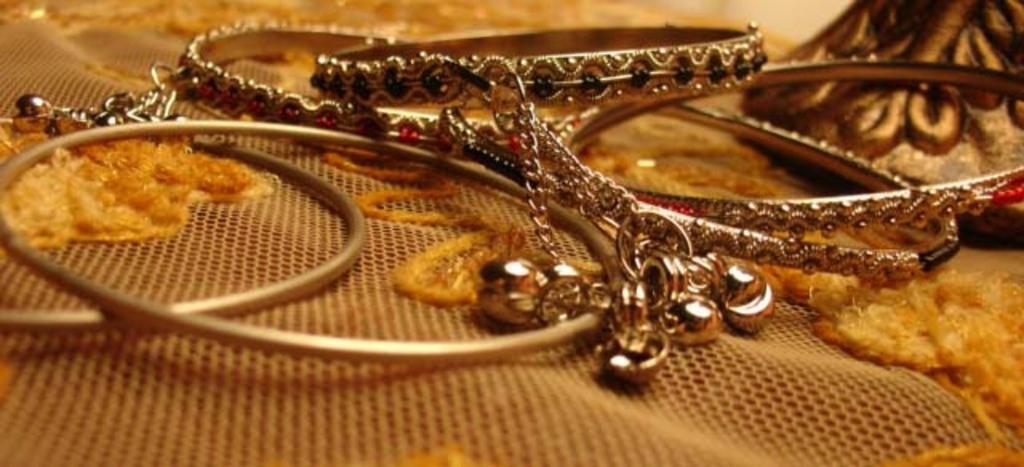Describe this image in one or two sentences. In the foreground of this image, there are bangles on an embroidered net cloth. On the right top, there is an object. 